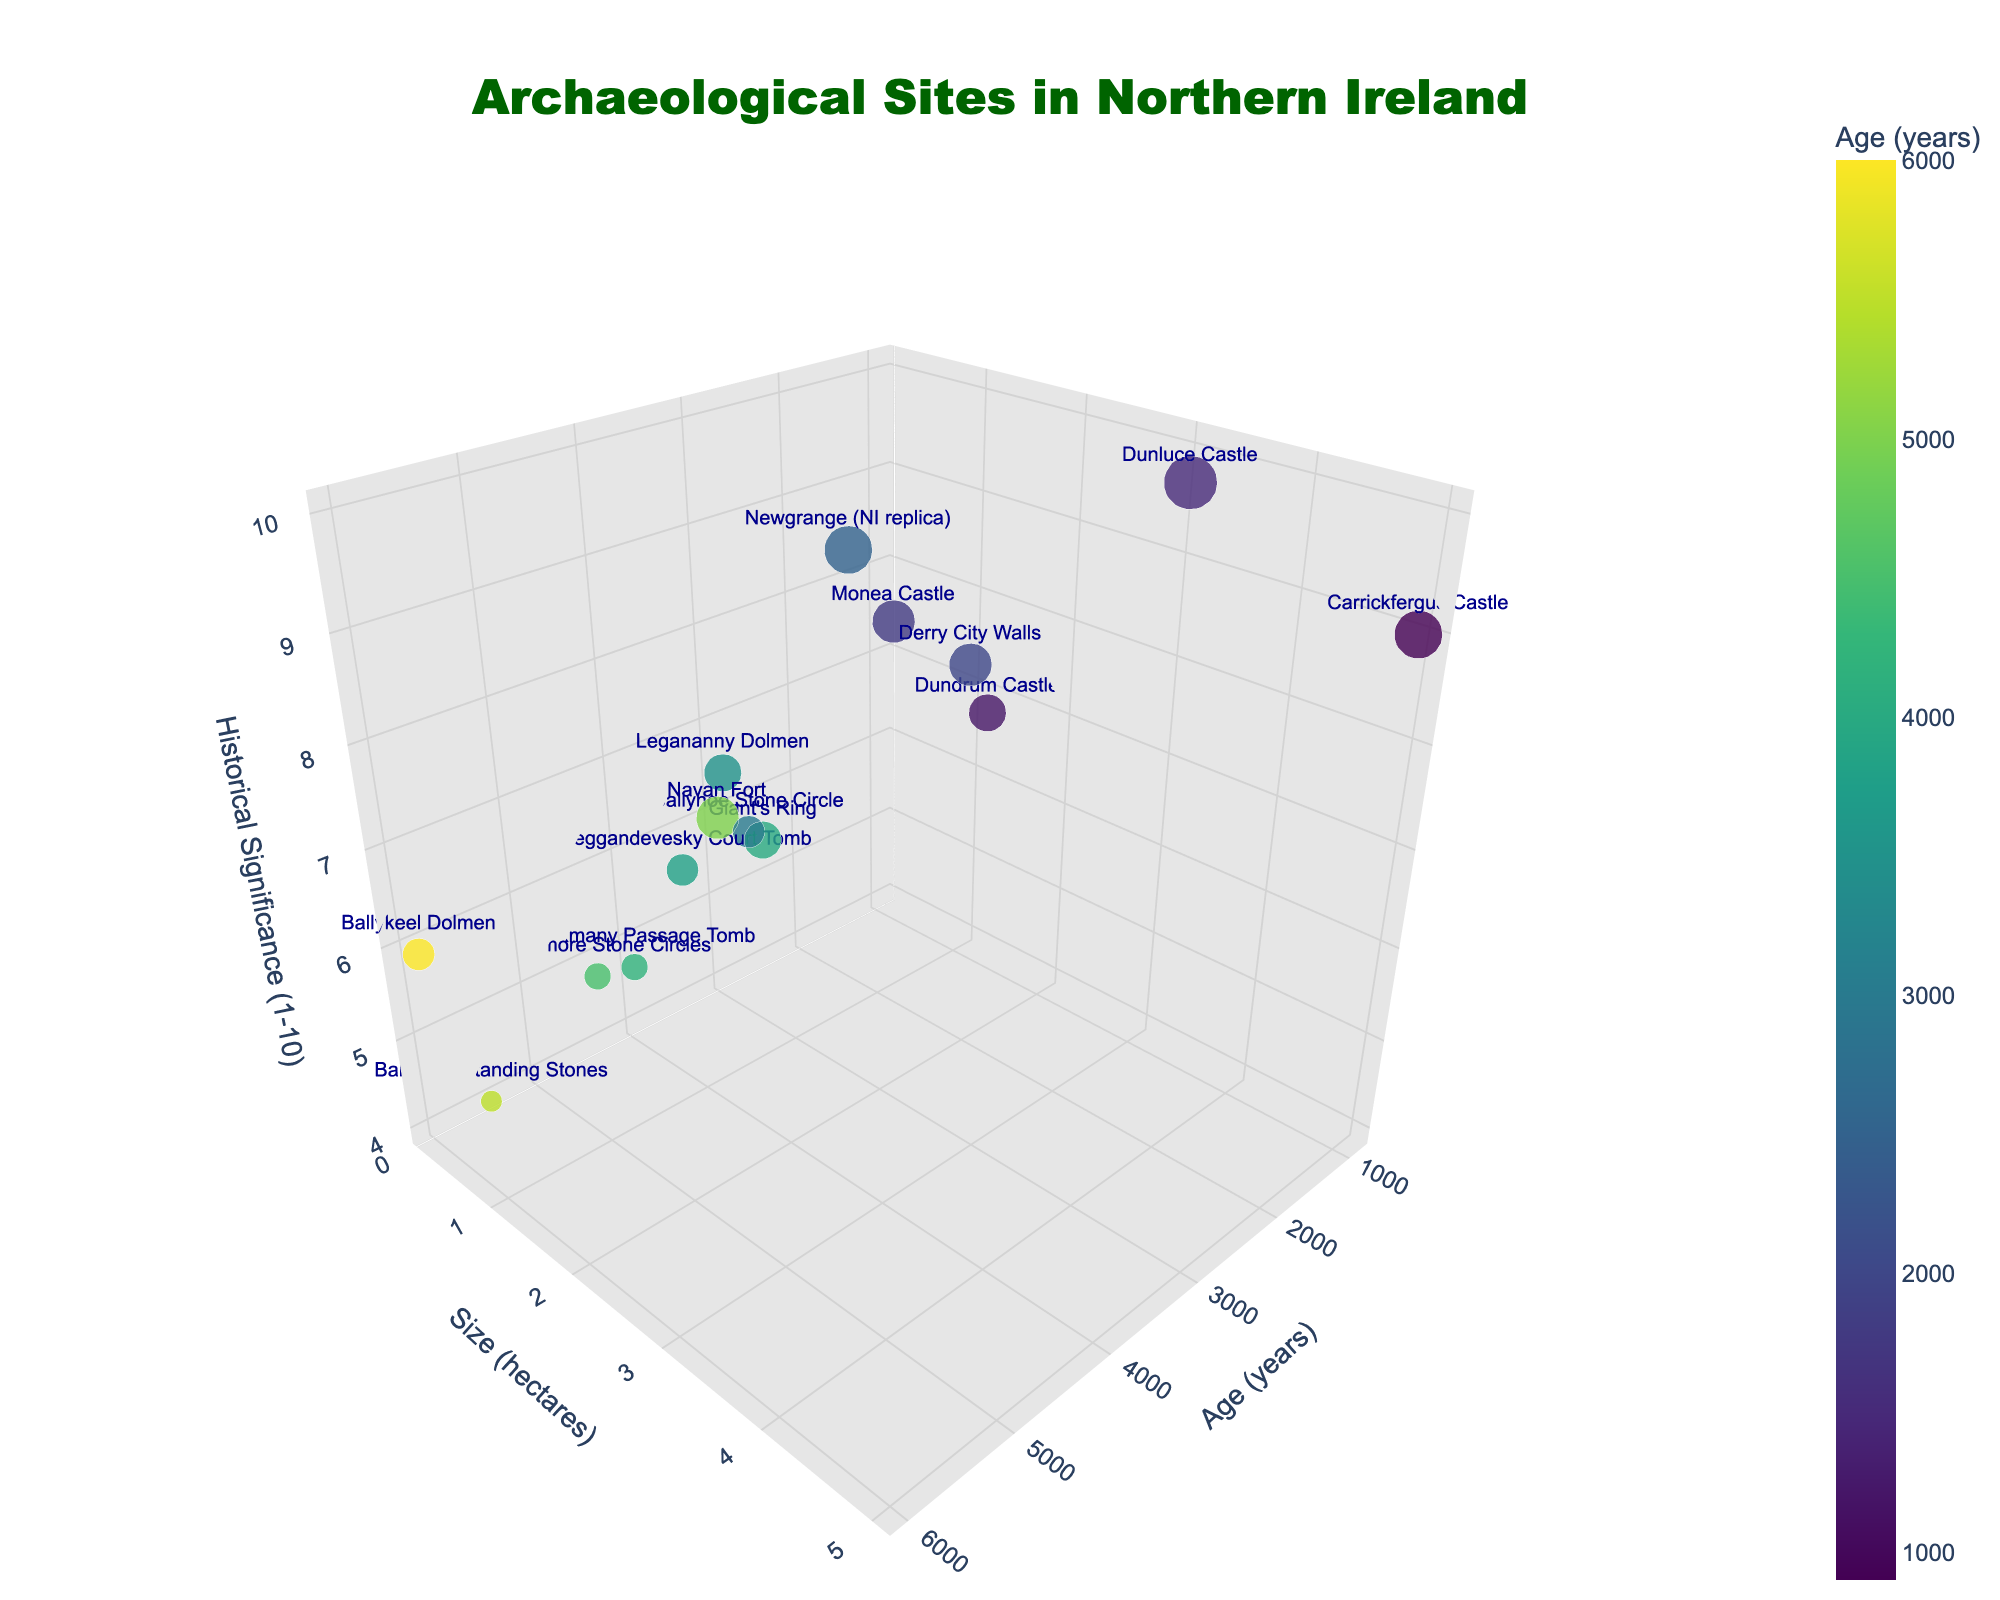Which archaeological site is the oldest? The site with the highest value on the Age (years) axis is the oldest. From the plot, Ballykeel Dolmen with 6000 years is the oldest.
Answer: Ballykeel Dolmen Which site has the highest historical significance? The point with the highest value on the Historical Significance axis represents the site with the highest significance. Dunluce Castle has a historical significance of 10.
Answer: Dunluce Castle What is the size of Carrickfergus Castle? Locate Carrickfergus Castle on the scatter plot and refer to its position on the Size (hectares) axis. It has a size of 5.0 hectares.
Answer: 5.0 hectares What is the difference in age between Newgrange (NI replica) and Derry City Walls? Find the ages of both sites: Newgrange (NI replica) is 2500 years old and Derry City Walls is 2000 years old. Calculate the difference: 2500 - 2000 = 500 years.
Answer: 500 years Which site is larger in size: Ballynoe Stone Circle or Legananny Dolmen? Compare the sizes of the two sites from their positions on the Size (hectares) axis. Ballynoe Stone Circle is 0.5 hectares, and Legananny Dolmen is 0.8 hectares. Legananny Dolmen is larger.
Answer: Legananny Dolmen Which site is historically more significant: Navan Fort or Giant's Ring? Compare the Historical Significance values of both sites. Navan Fort has a significance of 8, while Giant's Ring has a significance of 7. Navan Fort is more significant.
Answer: Navan Fort How many sites have a historical significance of 8 or higher? Count the number of points with z-values (Historical Significance) of 8 or higher. There are five such sites: Navan Fort, Newgrange (NI replica), Dunluce Castle, Carrickfergus Castle, and Derry City Walls.
Answer: 5 sites What is the average size of the sites with the highest historical significance? Only Dunluce Castle has a significance of 10. The size of Dunluce Castle is 3.5 hectares. Thus, the average size is 3.5 hectares.
Answer: 3.5 hectares 